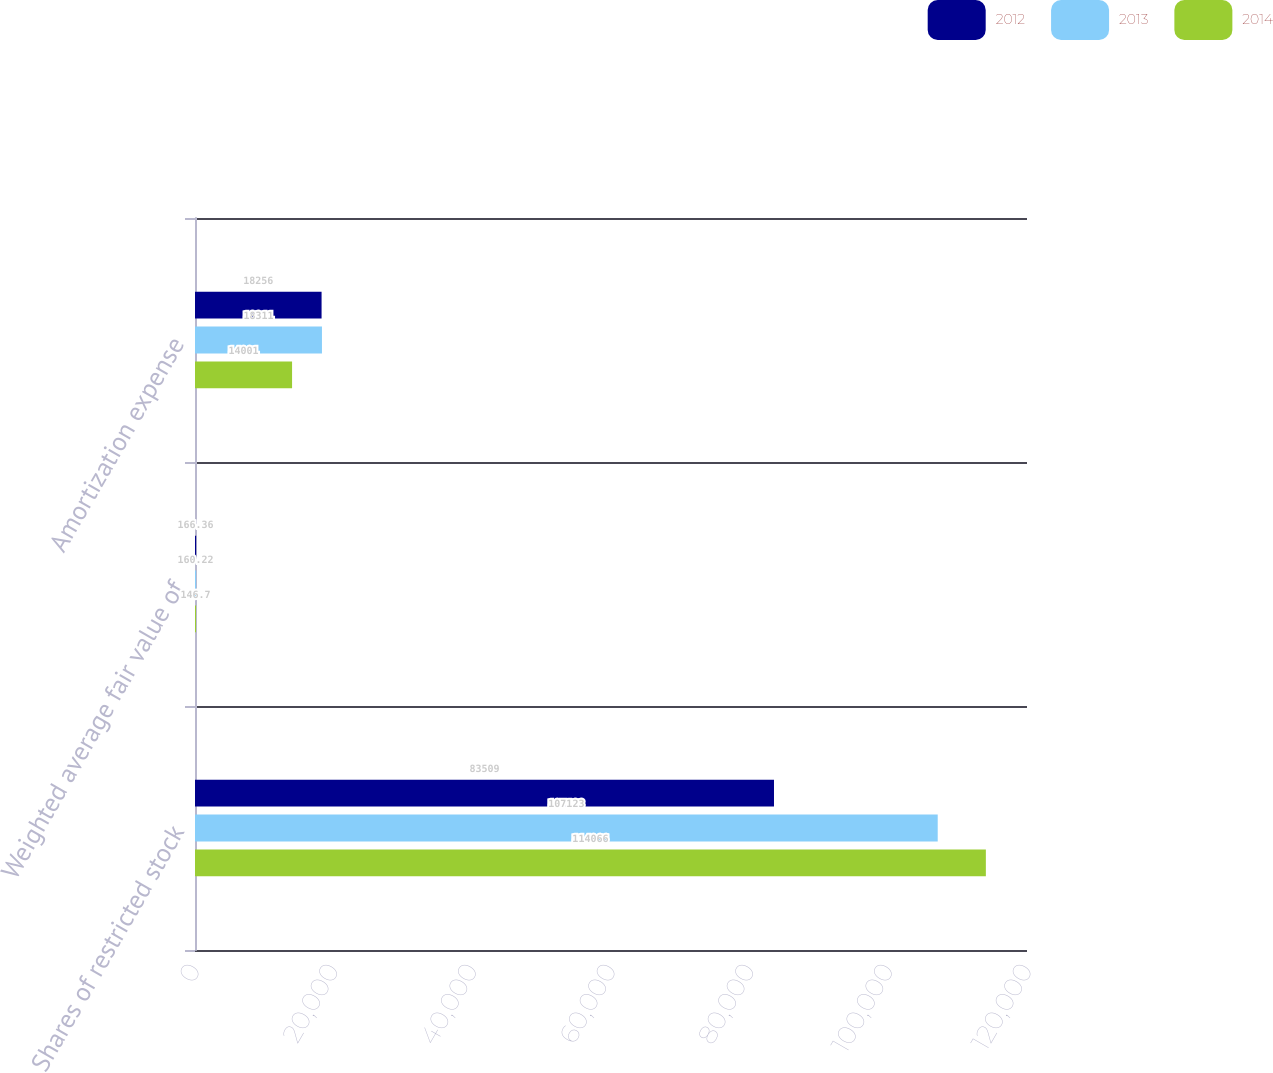Convert chart to OTSL. <chart><loc_0><loc_0><loc_500><loc_500><stacked_bar_chart><ecel><fcel>Shares of restricted stock<fcel>Weighted average fair value of<fcel>Amortization expense<nl><fcel>2012<fcel>83509<fcel>166.36<fcel>18256<nl><fcel>2013<fcel>107123<fcel>160.22<fcel>18311<nl><fcel>2014<fcel>114066<fcel>146.7<fcel>14001<nl></chart> 